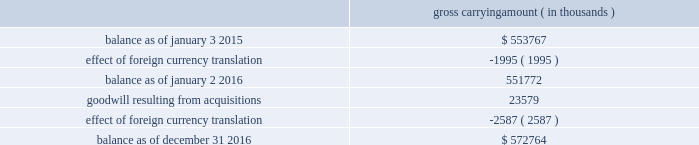Results of operations and the estimated fair value of acquired assets and assumed liabilities are recorded in the consolidated financial statements from the date of acquisition .
Pro forma results of operations for the business combinations completed during fiscal 2016 have not been presented because the effects of these acquisitions , individually and in the aggregate , would not have been material to cadence 2019s financial results .
The fair values of acquired intangible assets and assumed liabilities were determined using significant inputs that are not observable in the market .
For an additional description of these fair value calculations , see note 16 in the notes to the consolidated financial statements .
A trust for the benefit of the children of lip-bu tan , cadence 2019s president , chief executive officer , or ceo , and director , owned less than 2% ( 2 % ) of rocketick technologies ltd. , one of the acquired companies , and mr .
Tan and his wife serve as co-trustees of the trust and disclaim pecuniary and economic interest in the trust .
The board of directors of cadence reviewed the transaction and concluded that it was in the best interests of cadence to proceed with the transaction .
Mr .
Tan recused himself from the board of directors 2019 discussion of the valuation of rocketick technologies ltd .
And on whether to proceed with the transaction .
A financial advisor provided a fairness opinion to cadence in connection with the transaction .
2014 acquisitions during fiscal 2014 , cadence acquired jasper design automation , inc. , or jasper , a privately held provider of formal analysis solutions based in mountain view , california .
The acquired technology complements cadence 2019s existing system design and verification platforms .
Total cash consideration for jasper , after taking into account adjustments for certain costs , and cash held by jasper at closing of $ 28.7 million , was $ 139.4 million .
Cadence will also make payments to certain employees through the third quarter of fiscal 2017 subject to continued employment and other conditions .
Cadence also completed two other business combinations during fiscal 2014 for total cash consideration of $ 27.5 million , after taking into account cash acquired of $ 2.1 million .
Acquisition-related transaction costs transaction costs associated with acquisitions were $ 1.1 million , $ 0.7 million and $ 3.7 million during fiscal 2016 , 2015 and 2014 , respectively .
These costs consist of professional fees and administrative costs and were expensed as incurred in cadence 2019s consolidated income statements .
Note 8 .
Goodwill and acquired intangibles goodwill the changes in the carrying amount of goodwill during fiscal 2016 and 2015 were as follows : gross carrying amount ( in thousands ) .
Cadence completed its annual goodwill impairment test during the third quarter of fiscal 2016 and determined that the fair value of cadence 2019s single reporting unit substantially exceeded the carrying amount of its net assets and that no impairment existed. .
What is the percentage increase in gross carrying amount from the beginning of 2015 to the end of 2016? 
Computations: ((572764 - 553767) / 553767)
Answer: 0.03431. Results of operations and the estimated fair value of acquired assets and assumed liabilities are recorded in the consolidated financial statements from the date of acquisition .
Pro forma results of operations for the business combinations completed during fiscal 2016 have not been presented because the effects of these acquisitions , individually and in the aggregate , would not have been material to cadence 2019s financial results .
The fair values of acquired intangible assets and assumed liabilities were determined using significant inputs that are not observable in the market .
For an additional description of these fair value calculations , see note 16 in the notes to the consolidated financial statements .
A trust for the benefit of the children of lip-bu tan , cadence 2019s president , chief executive officer , or ceo , and director , owned less than 2% ( 2 % ) of rocketick technologies ltd. , one of the acquired companies , and mr .
Tan and his wife serve as co-trustees of the trust and disclaim pecuniary and economic interest in the trust .
The board of directors of cadence reviewed the transaction and concluded that it was in the best interests of cadence to proceed with the transaction .
Mr .
Tan recused himself from the board of directors 2019 discussion of the valuation of rocketick technologies ltd .
And on whether to proceed with the transaction .
A financial advisor provided a fairness opinion to cadence in connection with the transaction .
2014 acquisitions during fiscal 2014 , cadence acquired jasper design automation , inc. , or jasper , a privately held provider of formal analysis solutions based in mountain view , california .
The acquired technology complements cadence 2019s existing system design and verification platforms .
Total cash consideration for jasper , after taking into account adjustments for certain costs , and cash held by jasper at closing of $ 28.7 million , was $ 139.4 million .
Cadence will also make payments to certain employees through the third quarter of fiscal 2017 subject to continued employment and other conditions .
Cadence also completed two other business combinations during fiscal 2014 for total cash consideration of $ 27.5 million , after taking into account cash acquired of $ 2.1 million .
Acquisition-related transaction costs transaction costs associated with acquisitions were $ 1.1 million , $ 0.7 million and $ 3.7 million during fiscal 2016 , 2015 and 2014 , respectively .
These costs consist of professional fees and administrative costs and were expensed as incurred in cadence 2019s consolidated income statements .
Note 8 .
Goodwill and acquired intangibles goodwill the changes in the carrying amount of goodwill during fiscal 2016 and 2015 were as follows : gross carrying amount ( in thousands ) .
Cadence completed its annual goodwill impairment test during the third quarter of fiscal 2016 and determined that the fair value of cadence 2019s single reporting unit substantially exceeded the carrying amount of its net assets and that no impairment existed. .
What portion of the total carrying amount is generated by the goodwill from acquisitions? 
Computations: (23579 / 572764)
Answer: 0.04117. 